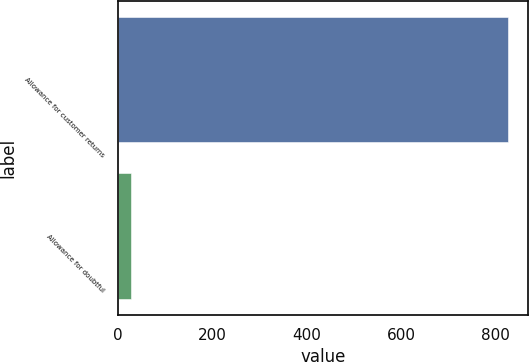Convert chart. <chart><loc_0><loc_0><loc_500><loc_500><bar_chart><fcel>Allowance for customer returns<fcel>Allowance for doubtful<nl><fcel>828<fcel>26<nl></chart> 